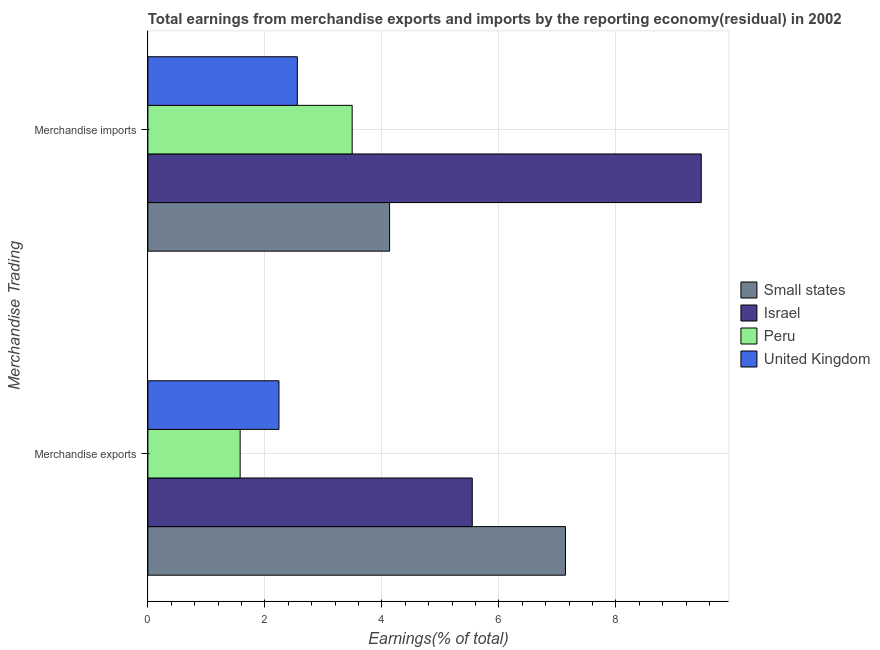How many different coloured bars are there?
Provide a succinct answer. 4. How many bars are there on the 2nd tick from the top?
Offer a terse response. 4. What is the label of the 2nd group of bars from the top?
Your answer should be very brief. Merchandise exports. What is the earnings from merchandise imports in Israel?
Keep it short and to the point. 9.46. Across all countries, what is the maximum earnings from merchandise imports?
Your response must be concise. 9.46. Across all countries, what is the minimum earnings from merchandise imports?
Offer a terse response. 2.55. In which country was the earnings from merchandise exports maximum?
Provide a short and direct response. Small states. In which country was the earnings from merchandise imports minimum?
Keep it short and to the point. United Kingdom. What is the total earnings from merchandise imports in the graph?
Your response must be concise. 19.64. What is the difference between the earnings from merchandise imports in Israel and that in United Kingdom?
Offer a very short reply. 6.9. What is the difference between the earnings from merchandise exports in United Kingdom and the earnings from merchandise imports in Peru?
Your answer should be very brief. -1.25. What is the average earnings from merchandise exports per country?
Make the answer very short. 4.12. What is the difference between the earnings from merchandise exports and earnings from merchandise imports in Peru?
Provide a succinct answer. -1.91. What is the ratio of the earnings from merchandise imports in Peru to that in Small states?
Your response must be concise. 0.85. In how many countries, is the earnings from merchandise exports greater than the average earnings from merchandise exports taken over all countries?
Offer a very short reply. 2. What does the 2nd bar from the bottom in Merchandise imports represents?
Ensure brevity in your answer.  Israel. How many bars are there?
Your answer should be compact. 8. Are all the bars in the graph horizontal?
Your answer should be very brief. Yes. Does the graph contain any zero values?
Keep it short and to the point. No. Does the graph contain grids?
Offer a terse response. Yes. What is the title of the graph?
Offer a very short reply. Total earnings from merchandise exports and imports by the reporting economy(residual) in 2002. What is the label or title of the X-axis?
Give a very brief answer. Earnings(% of total). What is the label or title of the Y-axis?
Give a very brief answer. Merchandise Trading. What is the Earnings(% of total) of Small states in Merchandise exports?
Provide a succinct answer. 7.14. What is the Earnings(% of total) in Israel in Merchandise exports?
Offer a very short reply. 5.54. What is the Earnings(% of total) in Peru in Merchandise exports?
Make the answer very short. 1.58. What is the Earnings(% of total) in United Kingdom in Merchandise exports?
Your answer should be very brief. 2.24. What is the Earnings(% of total) of Small states in Merchandise imports?
Your response must be concise. 4.13. What is the Earnings(% of total) in Israel in Merchandise imports?
Your answer should be compact. 9.46. What is the Earnings(% of total) in Peru in Merchandise imports?
Provide a short and direct response. 3.49. What is the Earnings(% of total) in United Kingdom in Merchandise imports?
Your response must be concise. 2.55. Across all Merchandise Trading, what is the maximum Earnings(% of total) in Small states?
Provide a succinct answer. 7.14. Across all Merchandise Trading, what is the maximum Earnings(% of total) of Israel?
Provide a succinct answer. 9.46. Across all Merchandise Trading, what is the maximum Earnings(% of total) of Peru?
Provide a short and direct response. 3.49. Across all Merchandise Trading, what is the maximum Earnings(% of total) in United Kingdom?
Your answer should be compact. 2.55. Across all Merchandise Trading, what is the minimum Earnings(% of total) in Small states?
Ensure brevity in your answer.  4.13. Across all Merchandise Trading, what is the minimum Earnings(% of total) in Israel?
Keep it short and to the point. 5.54. Across all Merchandise Trading, what is the minimum Earnings(% of total) in Peru?
Make the answer very short. 1.58. Across all Merchandise Trading, what is the minimum Earnings(% of total) in United Kingdom?
Make the answer very short. 2.24. What is the total Earnings(% of total) of Small states in the graph?
Provide a short and direct response. 11.27. What is the total Earnings(% of total) of Israel in the graph?
Make the answer very short. 15. What is the total Earnings(% of total) in Peru in the graph?
Give a very brief answer. 5.07. What is the total Earnings(% of total) of United Kingdom in the graph?
Ensure brevity in your answer.  4.8. What is the difference between the Earnings(% of total) of Small states in Merchandise exports and that in Merchandise imports?
Your answer should be very brief. 3.01. What is the difference between the Earnings(% of total) of Israel in Merchandise exports and that in Merchandise imports?
Provide a short and direct response. -3.91. What is the difference between the Earnings(% of total) of Peru in Merchandise exports and that in Merchandise imports?
Your answer should be very brief. -1.91. What is the difference between the Earnings(% of total) of United Kingdom in Merchandise exports and that in Merchandise imports?
Your answer should be compact. -0.31. What is the difference between the Earnings(% of total) in Small states in Merchandise exports and the Earnings(% of total) in Israel in Merchandise imports?
Offer a terse response. -2.32. What is the difference between the Earnings(% of total) of Small states in Merchandise exports and the Earnings(% of total) of Peru in Merchandise imports?
Make the answer very short. 3.65. What is the difference between the Earnings(% of total) of Small states in Merchandise exports and the Earnings(% of total) of United Kingdom in Merchandise imports?
Provide a succinct answer. 4.58. What is the difference between the Earnings(% of total) of Israel in Merchandise exports and the Earnings(% of total) of Peru in Merchandise imports?
Offer a terse response. 2.05. What is the difference between the Earnings(% of total) of Israel in Merchandise exports and the Earnings(% of total) of United Kingdom in Merchandise imports?
Your answer should be compact. 2.99. What is the difference between the Earnings(% of total) of Peru in Merchandise exports and the Earnings(% of total) of United Kingdom in Merchandise imports?
Provide a short and direct response. -0.98. What is the average Earnings(% of total) in Small states per Merchandise Trading?
Keep it short and to the point. 5.63. What is the average Earnings(% of total) of Israel per Merchandise Trading?
Provide a succinct answer. 7.5. What is the average Earnings(% of total) in Peru per Merchandise Trading?
Ensure brevity in your answer.  2.53. What is the average Earnings(% of total) in United Kingdom per Merchandise Trading?
Your answer should be very brief. 2.4. What is the difference between the Earnings(% of total) in Small states and Earnings(% of total) in Israel in Merchandise exports?
Your response must be concise. 1.59. What is the difference between the Earnings(% of total) of Small states and Earnings(% of total) of Peru in Merchandise exports?
Make the answer very short. 5.56. What is the difference between the Earnings(% of total) of Small states and Earnings(% of total) of United Kingdom in Merchandise exports?
Provide a succinct answer. 4.9. What is the difference between the Earnings(% of total) of Israel and Earnings(% of total) of Peru in Merchandise exports?
Your answer should be compact. 3.97. What is the difference between the Earnings(% of total) in Israel and Earnings(% of total) in United Kingdom in Merchandise exports?
Ensure brevity in your answer.  3.3. What is the difference between the Earnings(% of total) in Peru and Earnings(% of total) in United Kingdom in Merchandise exports?
Provide a short and direct response. -0.66. What is the difference between the Earnings(% of total) of Small states and Earnings(% of total) of Israel in Merchandise imports?
Offer a very short reply. -5.33. What is the difference between the Earnings(% of total) of Small states and Earnings(% of total) of Peru in Merchandise imports?
Keep it short and to the point. 0.64. What is the difference between the Earnings(% of total) in Small states and Earnings(% of total) in United Kingdom in Merchandise imports?
Make the answer very short. 1.58. What is the difference between the Earnings(% of total) in Israel and Earnings(% of total) in Peru in Merchandise imports?
Ensure brevity in your answer.  5.97. What is the difference between the Earnings(% of total) of Israel and Earnings(% of total) of United Kingdom in Merchandise imports?
Make the answer very short. 6.9. What is the difference between the Earnings(% of total) in Peru and Earnings(% of total) in United Kingdom in Merchandise imports?
Your answer should be compact. 0.94. What is the ratio of the Earnings(% of total) of Small states in Merchandise exports to that in Merchandise imports?
Keep it short and to the point. 1.73. What is the ratio of the Earnings(% of total) in Israel in Merchandise exports to that in Merchandise imports?
Keep it short and to the point. 0.59. What is the ratio of the Earnings(% of total) of Peru in Merchandise exports to that in Merchandise imports?
Give a very brief answer. 0.45. What is the ratio of the Earnings(% of total) of United Kingdom in Merchandise exports to that in Merchandise imports?
Make the answer very short. 0.88. What is the difference between the highest and the second highest Earnings(% of total) in Small states?
Give a very brief answer. 3.01. What is the difference between the highest and the second highest Earnings(% of total) in Israel?
Keep it short and to the point. 3.91. What is the difference between the highest and the second highest Earnings(% of total) in Peru?
Offer a terse response. 1.91. What is the difference between the highest and the second highest Earnings(% of total) of United Kingdom?
Your answer should be very brief. 0.31. What is the difference between the highest and the lowest Earnings(% of total) in Small states?
Offer a very short reply. 3.01. What is the difference between the highest and the lowest Earnings(% of total) in Israel?
Make the answer very short. 3.91. What is the difference between the highest and the lowest Earnings(% of total) of Peru?
Offer a very short reply. 1.91. What is the difference between the highest and the lowest Earnings(% of total) of United Kingdom?
Ensure brevity in your answer.  0.31. 